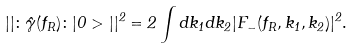Convert formula to latex. <formula><loc_0><loc_0><loc_500><loc_500>| | \colon \hat { \gamma } ( f _ { R } ) \colon | 0 > | | ^ { 2 } = 2 \int d k _ { 1 } d k _ { 2 } | F _ { - } ( f _ { R } , k _ { 1 } , k _ { 2 } ) | ^ { 2 } .</formula> 